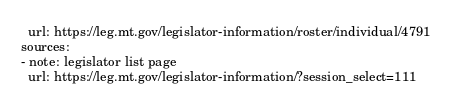<code> <loc_0><loc_0><loc_500><loc_500><_YAML_>  url: https://leg.mt.gov/legislator-information/roster/individual/4791
sources:
- note: legislator list page
  url: https://leg.mt.gov/legislator-information/?session_select=111
</code> 